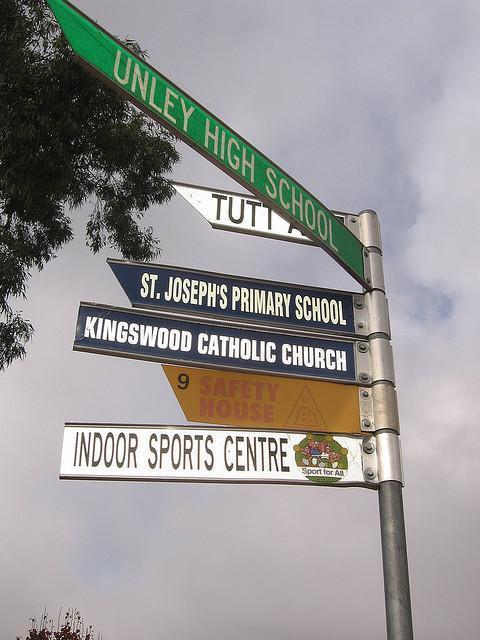How many signs are there?
Give a very brief answer. 6. 